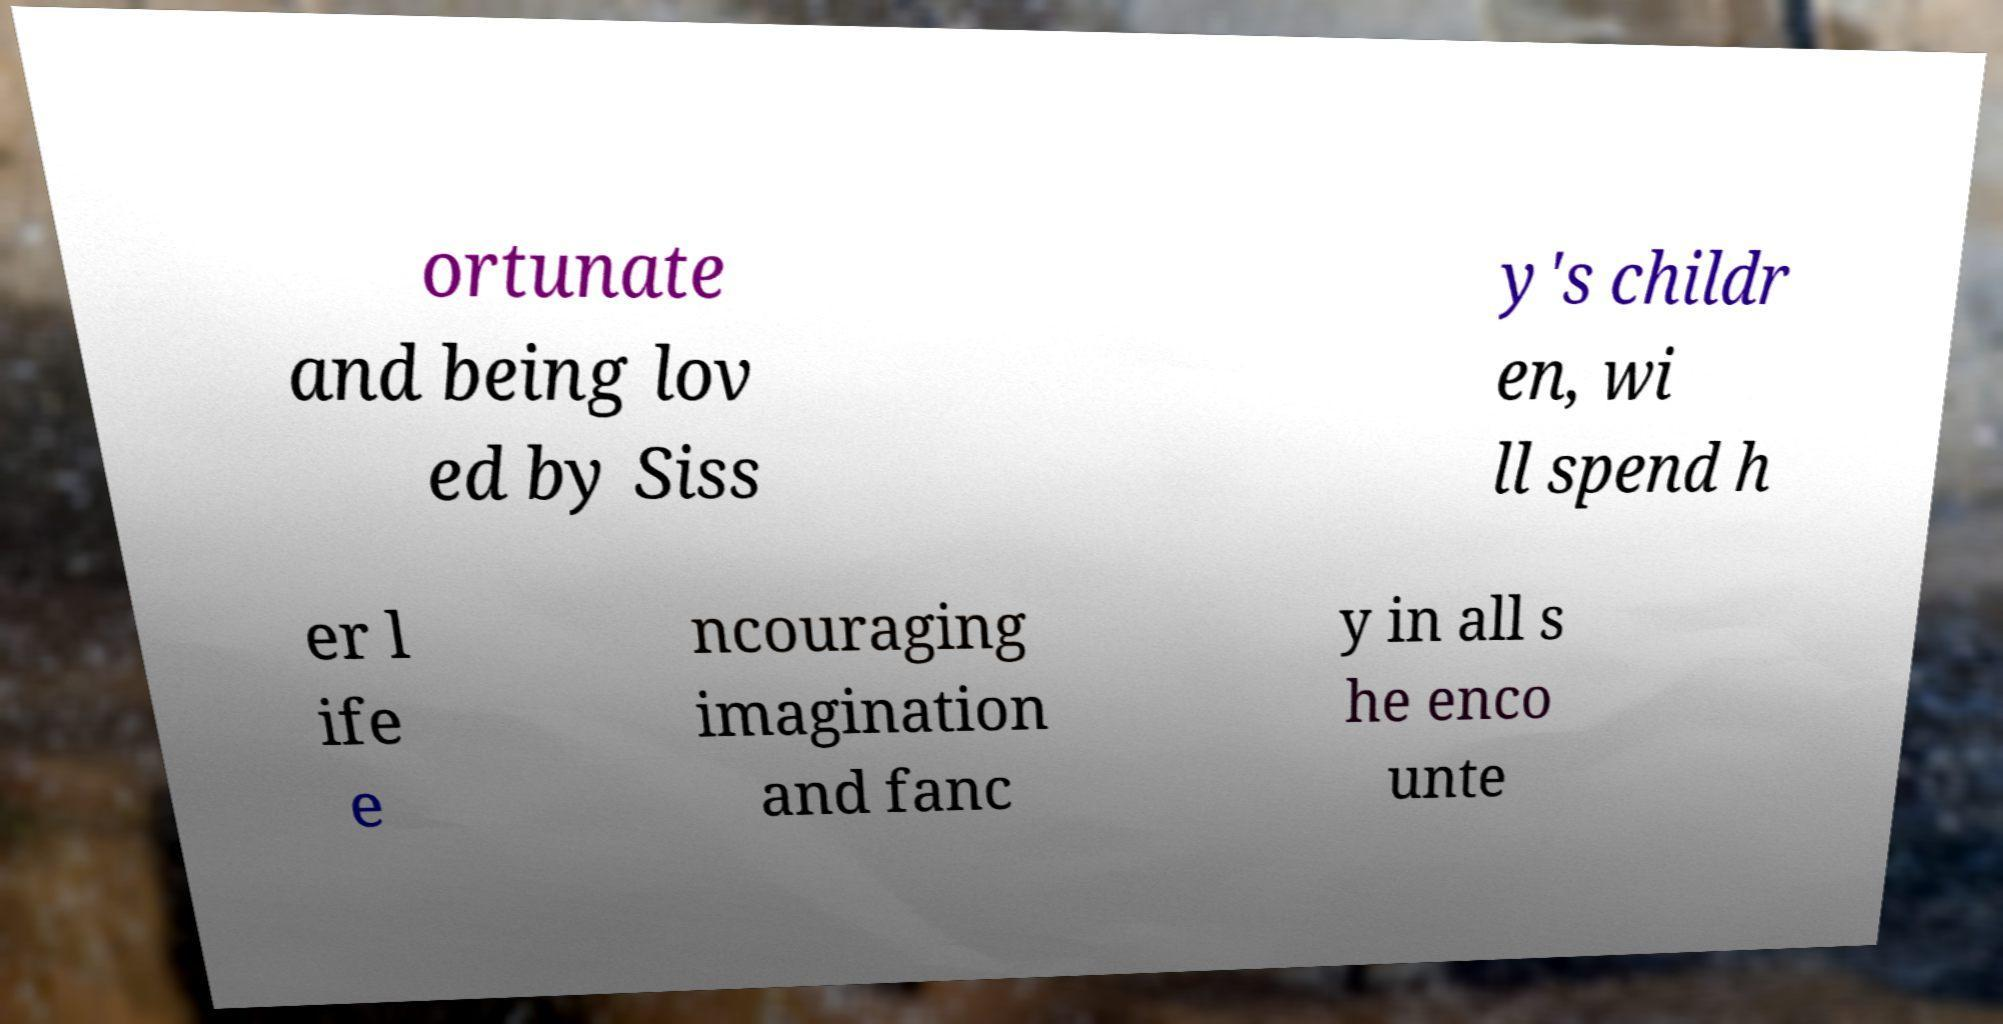Could you extract and type out the text from this image? ortunate and being lov ed by Siss y's childr en, wi ll spend h er l ife e ncouraging imagination and fanc y in all s he enco unte 